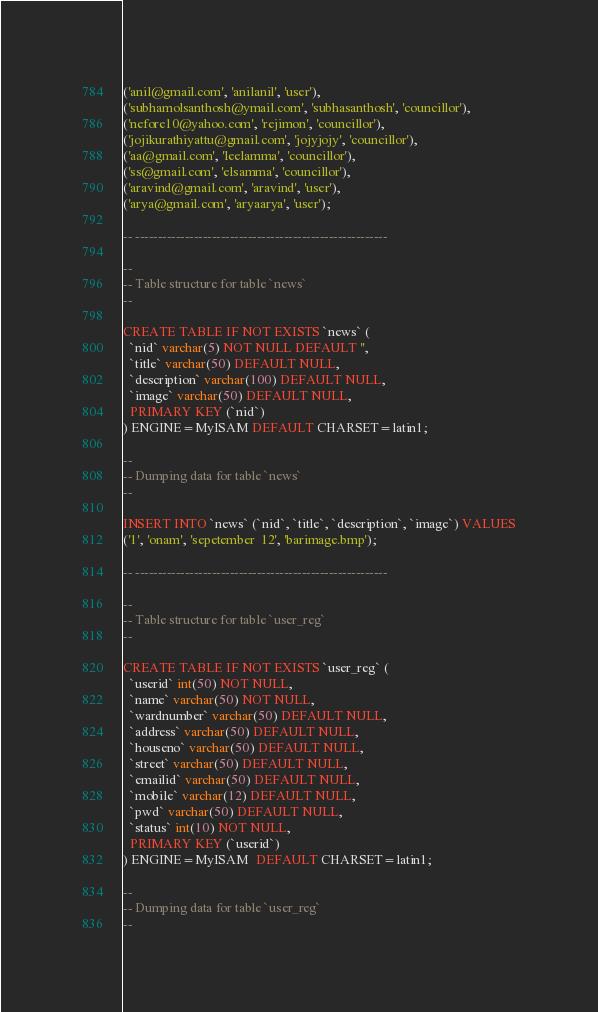<code> <loc_0><loc_0><loc_500><loc_500><_SQL_>('anil@gmail.com', 'anilanil', 'user'),
('subhamolsanthosh@ymail.com', 'subhasanthosh', 'councillor'),
('nefore10@yahoo.com', 'rejimon', 'councillor'),
('jojikurathiyattu@gmail.com', 'jojyjojy', 'councillor'),
('aa@gmail.com', 'leelamma', 'councillor'),
('ss@gmail.com', 'elsamma', 'councillor'),
('aravind@gmail.com', 'aravind', 'user'),
('arya@gmail.com', 'aryaarya', 'user');

-- --------------------------------------------------------

--
-- Table structure for table `news`
--

CREATE TABLE IF NOT EXISTS `news` (
  `nid` varchar(5) NOT NULL DEFAULT '',
  `title` varchar(50) DEFAULT NULL,
  `description` varchar(100) DEFAULT NULL,
  `image` varchar(50) DEFAULT NULL,
  PRIMARY KEY (`nid`)
) ENGINE=MyISAM DEFAULT CHARSET=latin1;

--
-- Dumping data for table `news`
--

INSERT INTO `news` (`nid`, `title`, `description`, `image`) VALUES
('1', 'onam', 'sepetember  12', 'barimage.bmp');

-- --------------------------------------------------------

--
-- Table structure for table `user_reg`
--

CREATE TABLE IF NOT EXISTS `user_reg` (
  `userid` int(50) NOT NULL,
  `name` varchar(50) NOT NULL,
  `wardnumber` varchar(50) DEFAULT NULL,
  `address` varchar(50) DEFAULT NULL,
  `houseno` varchar(50) DEFAULT NULL,
  `street` varchar(50) DEFAULT NULL,
  `emailid` varchar(50) DEFAULT NULL,
  `mobile` varchar(12) DEFAULT NULL,
  `pwd` varchar(50) DEFAULT NULL,
  `status` int(10) NOT NULL,
  PRIMARY KEY (`userid`)
) ENGINE=MyISAM  DEFAULT CHARSET=latin1;

--
-- Dumping data for table `user_reg`
--
</code> 